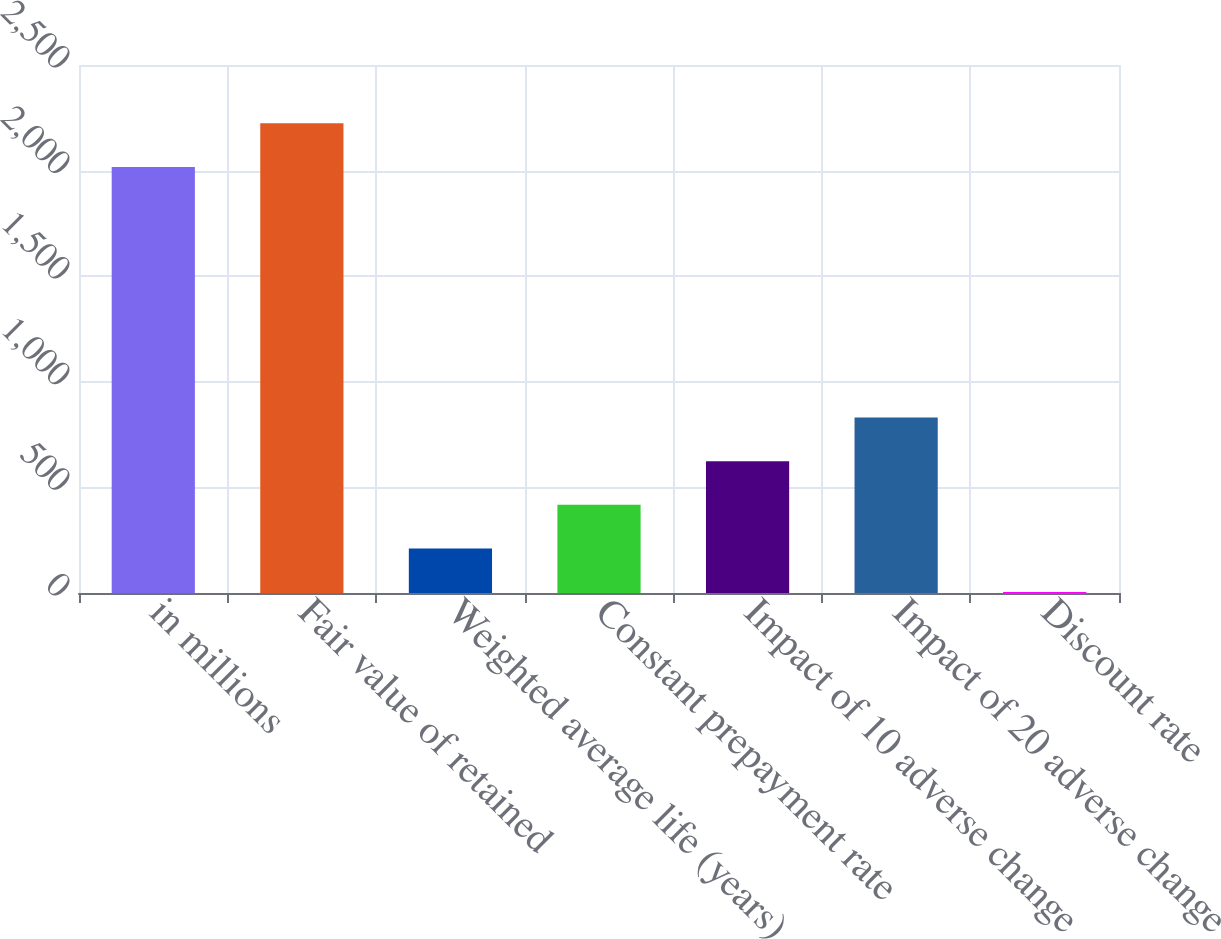<chart> <loc_0><loc_0><loc_500><loc_500><bar_chart><fcel>in millions<fcel>Fair value of retained<fcel>Weighted average life (years)<fcel>Constant prepayment rate<fcel>Impact of 10 adverse change<fcel>Impact of 20 adverse change<fcel>Discount rate<nl><fcel>2017<fcel>2223.68<fcel>210.88<fcel>417.56<fcel>624.24<fcel>830.92<fcel>4.2<nl></chart> 